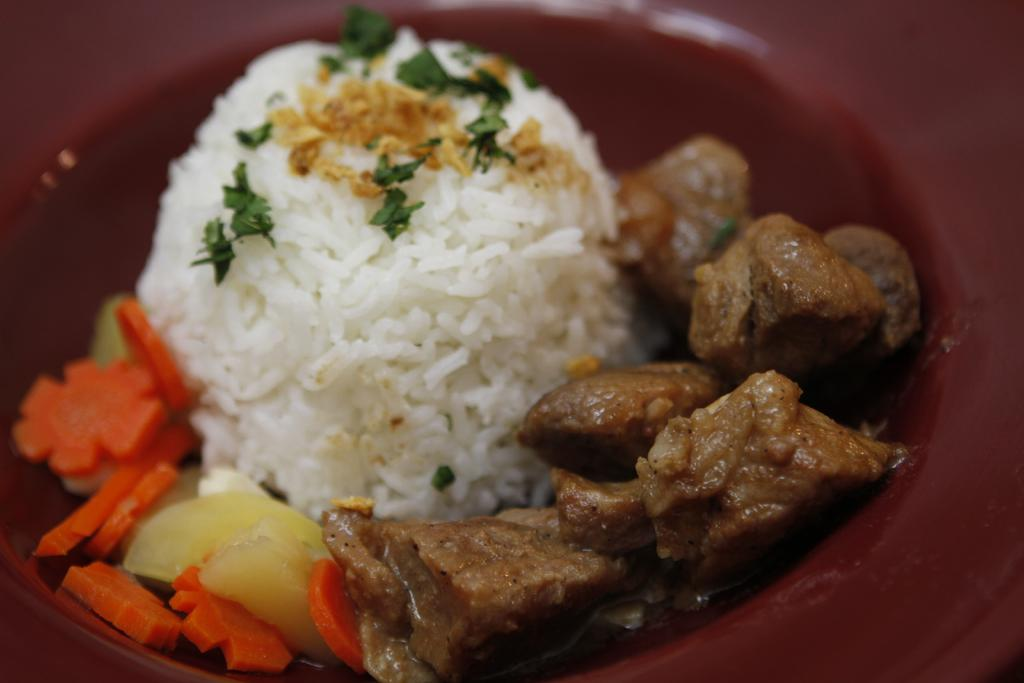What is in the bowl that is visible in the image? There is a bowl in the image, and it contains rice, meat, and carrot slices. What type of dish might this bowl represent? This bowl could represent a rice dish with meat and vegetables, such as a stir-fry or a rice bowl. Can you describe the contents of the bowl in more detail? The bowl contains rice, meat, and carrot slices. What type of stage can be seen in the background of the image? There is no stage present in the image; it only features a bowl with rice, meat, and carrot slices. 